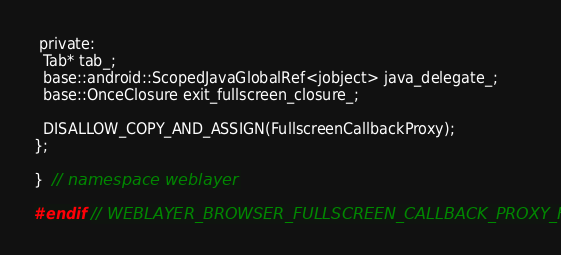Convert code to text. <code><loc_0><loc_0><loc_500><loc_500><_C_>
 private:
  Tab* tab_;
  base::android::ScopedJavaGlobalRef<jobject> java_delegate_;
  base::OnceClosure exit_fullscreen_closure_;

  DISALLOW_COPY_AND_ASSIGN(FullscreenCallbackProxy);
};

}  // namespace weblayer

#endif  // WEBLAYER_BROWSER_FULLSCREEN_CALLBACK_PROXY_H_
</code> 